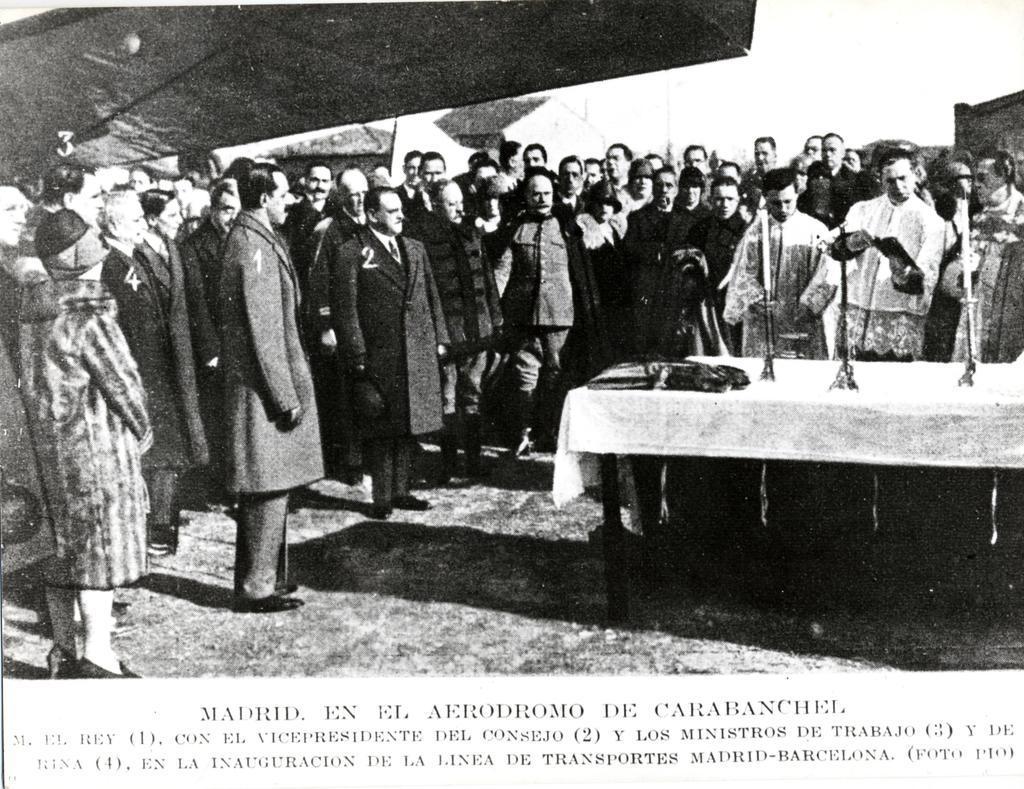In one or two sentences, can you explain what this image depicts? This is a black and white picture. In this picture we can see a few people standing on the path from left to right. There are a few objects and a white cloth on the table. We can see some text at the bottom. 